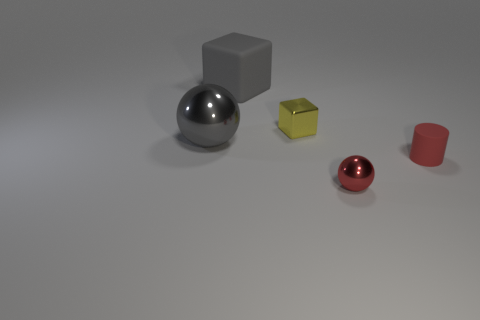Subtract all cylinders. How many objects are left? 4 Add 1 small cyan rubber cubes. How many objects exist? 6 Add 4 red objects. How many red objects are left? 6 Add 1 tiny red rubber cylinders. How many tiny red rubber cylinders exist? 2 Subtract 0 green spheres. How many objects are left? 5 Subtract 1 balls. How many balls are left? 1 Subtract all red cubes. Subtract all yellow cylinders. How many cubes are left? 2 Subtract all cyan cylinders. How many yellow cubes are left? 1 Subtract all cylinders. Subtract all small yellow objects. How many objects are left? 3 